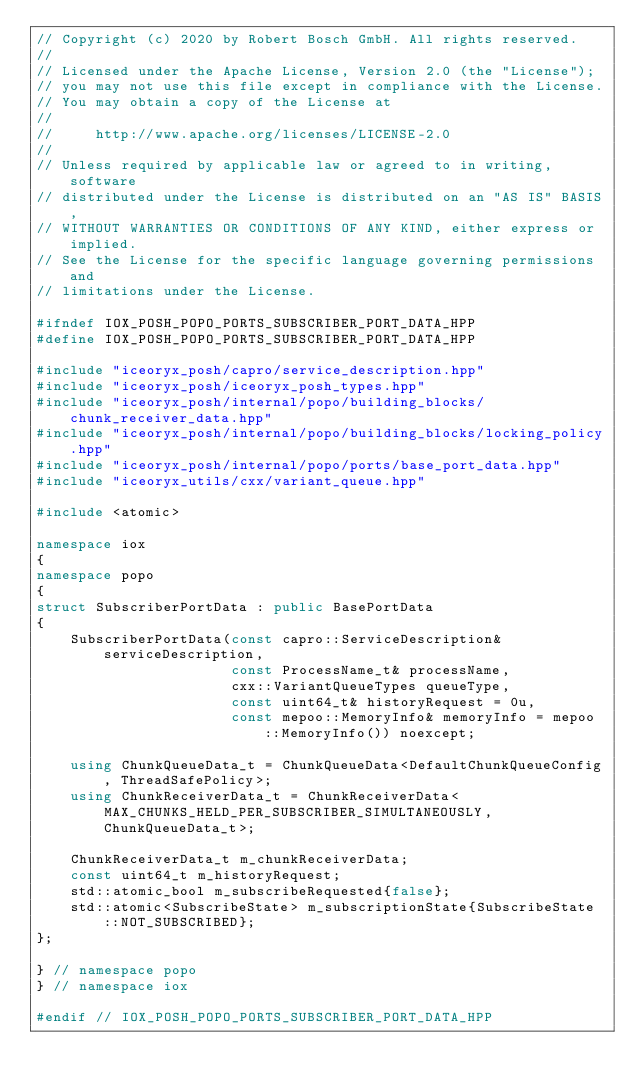<code> <loc_0><loc_0><loc_500><loc_500><_C++_>// Copyright (c) 2020 by Robert Bosch GmbH. All rights reserved.
//
// Licensed under the Apache License, Version 2.0 (the "License");
// you may not use this file except in compliance with the License.
// You may obtain a copy of the License at
//
//     http://www.apache.org/licenses/LICENSE-2.0
//
// Unless required by applicable law or agreed to in writing, software
// distributed under the License is distributed on an "AS IS" BASIS,
// WITHOUT WARRANTIES OR CONDITIONS OF ANY KIND, either express or implied.
// See the License for the specific language governing permissions and
// limitations under the License.

#ifndef IOX_POSH_POPO_PORTS_SUBSCRIBER_PORT_DATA_HPP
#define IOX_POSH_POPO_PORTS_SUBSCRIBER_PORT_DATA_HPP

#include "iceoryx_posh/capro/service_description.hpp"
#include "iceoryx_posh/iceoryx_posh_types.hpp"
#include "iceoryx_posh/internal/popo/building_blocks/chunk_receiver_data.hpp"
#include "iceoryx_posh/internal/popo/building_blocks/locking_policy.hpp"
#include "iceoryx_posh/internal/popo/ports/base_port_data.hpp"
#include "iceoryx_utils/cxx/variant_queue.hpp"

#include <atomic>

namespace iox
{
namespace popo
{
struct SubscriberPortData : public BasePortData
{
    SubscriberPortData(const capro::ServiceDescription& serviceDescription,
                       const ProcessName_t& processName,
                       cxx::VariantQueueTypes queueType,
                       const uint64_t& historyRequest = 0u,
                       const mepoo::MemoryInfo& memoryInfo = mepoo::MemoryInfo()) noexcept;

    using ChunkQueueData_t = ChunkQueueData<DefaultChunkQueueConfig, ThreadSafePolicy>;
    using ChunkReceiverData_t = ChunkReceiverData<MAX_CHUNKS_HELD_PER_SUBSCRIBER_SIMULTANEOUSLY, ChunkQueueData_t>;

    ChunkReceiverData_t m_chunkReceiverData;
    const uint64_t m_historyRequest;
    std::atomic_bool m_subscribeRequested{false};
    std::atomic<SubscribeState> m_subscriptionState{SubscribeState::NOT_SUBSCRIBED};
};

} // namespace popo
} // namespace iox

#endif // IOX_POSH_POPO_PORTS_SUBSCRIBER_PORT_DATA_HPP
</code> 